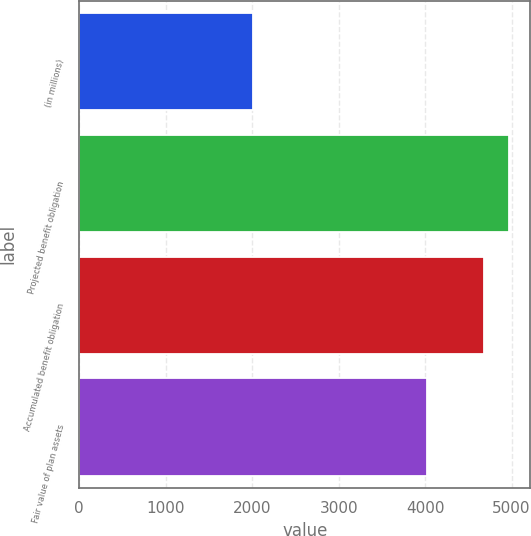Convert chart. <chart><loc_0><loc_0><loc_500><loc_500><bar_chart><fcel>(in millions)<fcel>Projected benefit obligation<fcel>Accumulated benefit obligation<fcel>Fair value of plan assets<nl><fcel>2013<fcel>4969.9<fcel>4683<fcel>4024<nl></chart> 